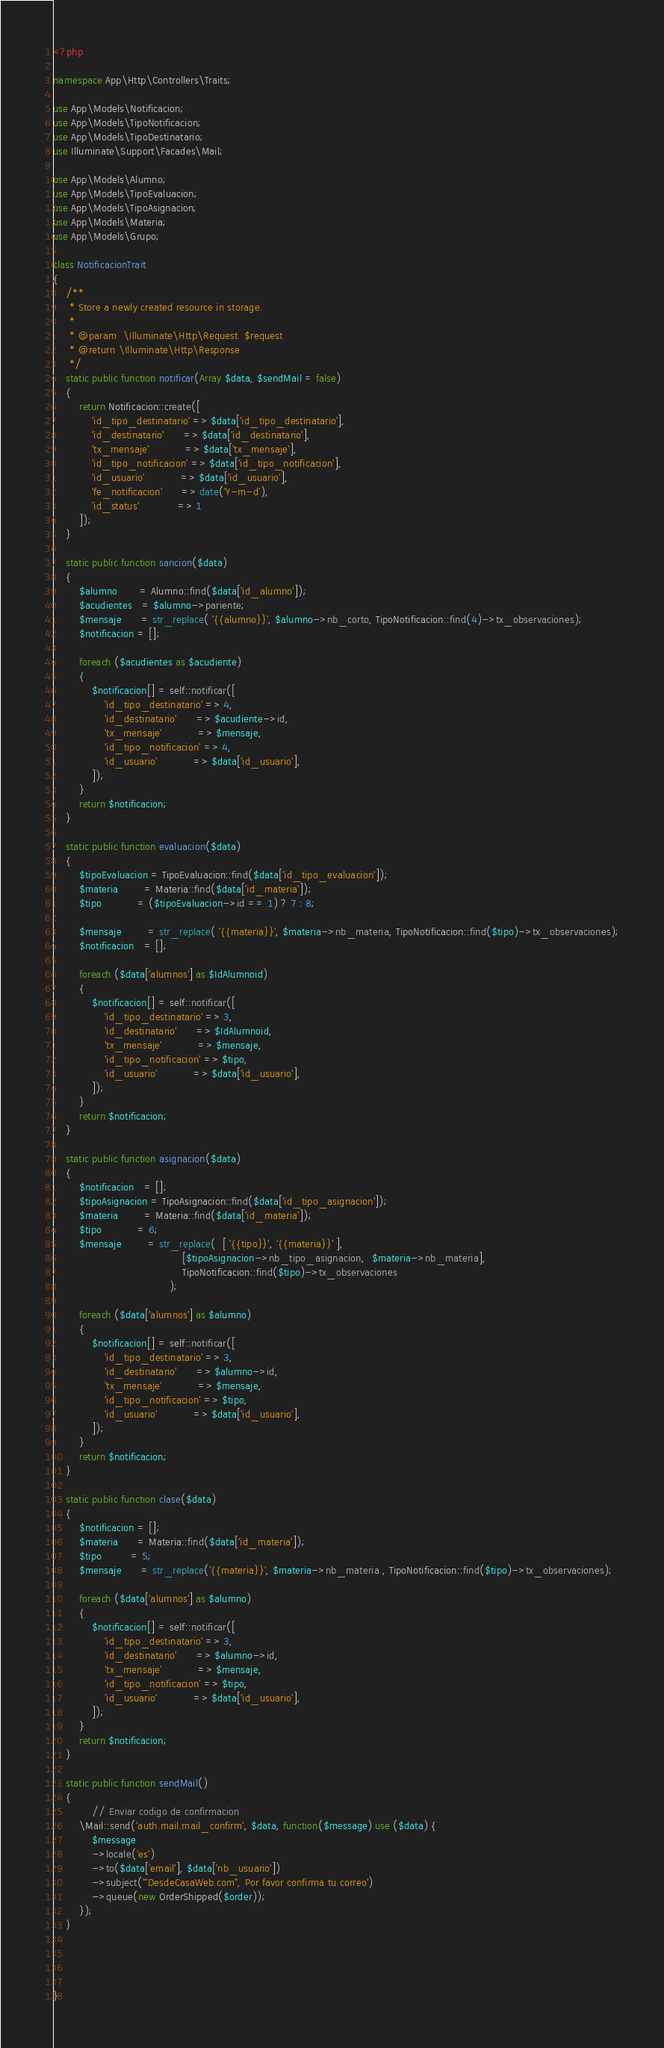Convert code to text. <code><loc_0><loc_0><loc_500><loc_500><_PHP_><?php

namespace App\Http\Controllers\Traits;

use App\Models\Notificacion;
use App\Models\TipoNotificacion;
use App\Models\TipoDestinatario;
use Illuminate\Support\Facades\Mail;

use App\Models\Alumno;
use App\Models\TipoEvaluacion;
use App\Models\TipoAsignacion;
use App\Models\Materia;
use App\Models\Grupo;

class NotificacionTrait
{
    /**
     * Store a newly created resource in storage.
     *
     * @param  \Illuminate\Http\Request  $request
     * @return \Illuminate\Http\Response
     */
    static public function notificar(Array $data, $sendMail = false)
    {
        return Notificacion::create([
            'id_tipo_destinatario' => $data['id_tipo_destinatario'],
			'id_destinatario'      => $data['id_destinatario'],
			'tx_mensaje'           => $data['tx_mensaje'],
            'id_tipo_notificacion' => $data['id_tipo_notificacion'],
            'id_usuario'           => $data['id_usuario'],
            'fe_notificacion'      => date('Y-m-d'), 
            'id_status'            => 1 
        ]);
    }

    static public function sancion($data)
    {
        $alumno       = Alumno::find($data['id_alumno']);
        $acudientes   = $alumno->pariente;
        $mensaje      = str_replace( '{{alumno}}', $alumno->nb_corto, TipoNotificacion::find(4)->tx_observaciones);
        $notificacion = [];
        
        foreach ($acudientes as $acudiente) 
        {
            $notificacion[] = self::notificar([
                'id_tipo_destinatario' => 4,
                'id_destinatario'      => $acudiente->id,
                'tx_mensaje'           => $mensaje,
                'id_tipo_notificacion' => 4,
                'id_usuario'           => $data['id_usuario'],
            ]);
        }
        return $notificacion;
    }

    static public function evaluacion($data)
    {
        $tipoEvaluacion = TipoEvaluacion::find($data['id_tipo_evaluacion']);
        $materia        = Materia::find($data['id_materia']);
        $tipo           = ($tipoEvaluacion->id == 1) ? 7 : 8;

        $mensaje        = str_replace( '{{materia}}', $materia->nb_materia, TipoNotificacion::find($tipo)->tx_observaciones);
        $notificacion   = [];
        
        foreach ($data['alumnos'] as $IdAlumnoid) 
        {
            $notificacion[] = self::notificar([
                'id_tipo_destinatario' => 3,
                'id_destinatario'      => $IdAlumnoid,
                'tx_mensaje'           => $mensaje,
                'id_tipo_notificacion' => $tipo,
                'id_usuario'           => $data['id_usuario'],
            ]);
        }
        return $notificacion;
    }

    static public function asignacion($data)
    {
        $notificacion   = [];
        $tipoAsignacion = TipoAsignacion::find($data['id_tipo_asignacion']);
        $materia        = Materia::find($data['id_materia']);
        $tipo           = 6;
        $mensaje        = str_replace(  [ '{{tipo}}', '{{materia}}' ], 
                                        [$tipoAsignacion->nb_tipo_asignacion,  $materia->nb_materia], 
                                        TipoNotificacion::find($tipo)->tx_observaciones
                                    );
        
        foreach ($data['alumnos'] as $alumno) 
        {
            $notificacion[] = self::notificar([
                'id_tipo_destinatario' => 3,
                'id_destinatario'      => $alumno->id,
                'tx_mensaje'           => $mensaje,
                'id_tipo_notificacion' => $tipo,
                'id_usuario'           => $data['id_usuario'],
            ]);
        }
        return $notificacion;
    }

    static public function clase($data)
    {
        $notificacion = [];
        $materia      = Materia::find($data['id_materia']);
        $tipo         = 5;
        $mensaje      = str_replace('{{materia}}', $materia->nb_materia , TipoNotificacion::find($tipo)->tx_observaciones);
        
        foreach ($data['alumnos'] as $alumno) 
        {
            $notificacion[] = self::notificar([
                'id_tipo_destinatario' => 3,
                'id_destinatario'      => $alumno->id,
                'tx_mensaje'           => $mensaje,
                'id_tipo_notificacion' => $tipo,
                'id_usuario'           => $data['id_usuario'],
            ]);
        }
        return $notificacion;
    }

    static public function sendMail()
    {
            // Enviar codigo de confirmacion
        \Mail::send('auth.mail.mail_confirm', $data, function($message) use ($data) {
            $message
            ->locale('es')
            ->to($data['email'], $data['nb_usuario'])
            ->subject('"DesdeCasaWeb.com", Por favor confirma tu correo')
            ->queue(new OrderShipped($order));
        });
    }

    

  
}</code> 